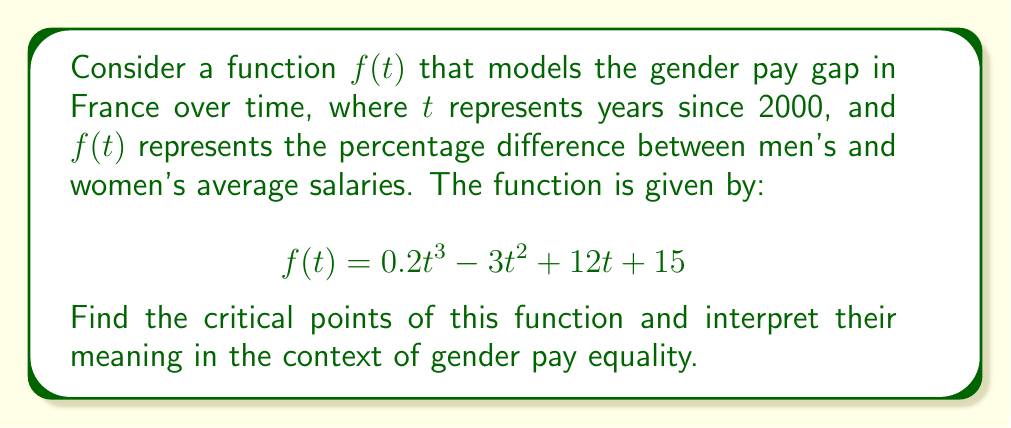Give your solution to this math problem. To find the critical points of the function $f(t)$, we need to follow these steps:

1) First, we find the derivative of $f(t)$:
   $$f'(t) = 0.6t^2 - 6t + 12$$

2) Set the derivative equal to zero and solve for t:
   $$0.6t^2 - 6t + 12 = 0$$

3) This is a quadratic equation. We can solve it using the quadratic formula:
   $$t = \frac{-b \pm \sqrt{b^2 - 4ac}}{2a}$$
   where $a = 0.6$, $b = -6$, and $c = 12$

4) Substituting these values:
   $$t = \frac{6 \pm \sqrt{36 - 28.8}}{1.2} = \frac{6 \pm \sqrt{7.2}}{1.2}$$

5) Simplifying:
   $$t = \frac{6 \pm 2.68}{1.2} = 5 \pm 2.23$$

6) Therefore, the critical points are:
   $$t_1 = 5 - 2.23 \approx 2.77$$
   $$t_2 = 5 + 2.23 \approx 7.23$$

Interpretation:
The critical points represent the years (since 2000) where the rate of change in the gender pay gap is zero. At these points, the pay gap is either at a local maximum or minimum.

- Around 2002-2003 (t ≈ 2.77), there was a turning point in the gender pay gap trend.
- Around 2007-2008 (t ≈ 7.23), there was another turning point.

These points could represent periods where policies or societal changes had significant impacts on gender pay equality in France.
Answer: The critical points are $t \approx 2.77$ and $t \approx 7.23$, corresponding to approximately the years 2002-2003 and 2007-2008 respectively. 